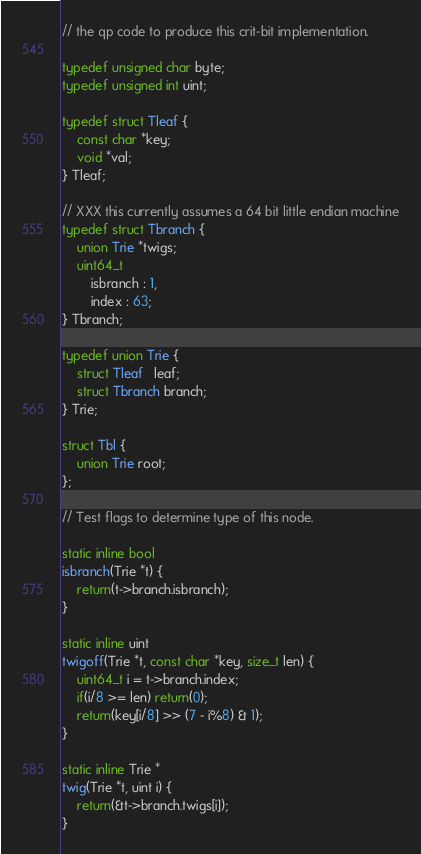Convert code to text. <code><loc_0><loc_0><loc_500><loc_500><_C_>// the qp code to produce this crit-bit implementation.

typedef unsigned char byte;
typedef unsigned int uint;

typedef struct Tleaf {
	const char *key;
	void *val;
} Tleaf;

// XXX this currently assumes a 64 bit little endian machine
typedef struct Tbranch {
	union Trie *twigs;
	uint64_t
		isbranch : 1,
		index : 63;
} Tbranch;

typedef union Trie {
	struct Tleaf   leaf;
	struct Tbranch branch;
} Trie;

struct Tbl {
	union Trie root;
};

// Test flags to determine type of this node.

static inline bool
isbranch(Trie *t) {
	return(t->branch.isbranch);
}

static inline uint
twigoff(Trie *t, const char *key, size_t len) {
	uint64_t i = t->branch.index;
	if(i/8 >= len) return(0);
	return(key[i/8] >> (7 - i%8) & 1);
}

static inline Trie *
twig(Trie *t, uint i) {
	return(&t->branch.twigs[i]);
}
</code> 